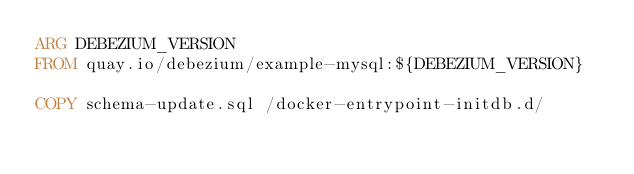<code> <loc_0><loc_0><loc_500><loc_500><_Dockerfile_>ARG DEBEZIUM_VERSION
FROM quay.io/debezium/example-mysql:${DEBEZIUM_VERSION}

COPY schema-update.sql /docker-entrypoint-initdb.d/
</code> 